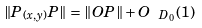<formula> <loc_0><loc_0><loc_500><loc_500>\| P _ { ( x , y ) } P \| = \| O P \| + O _ { \ D _ { 0 } } ( 1 )</formula> 